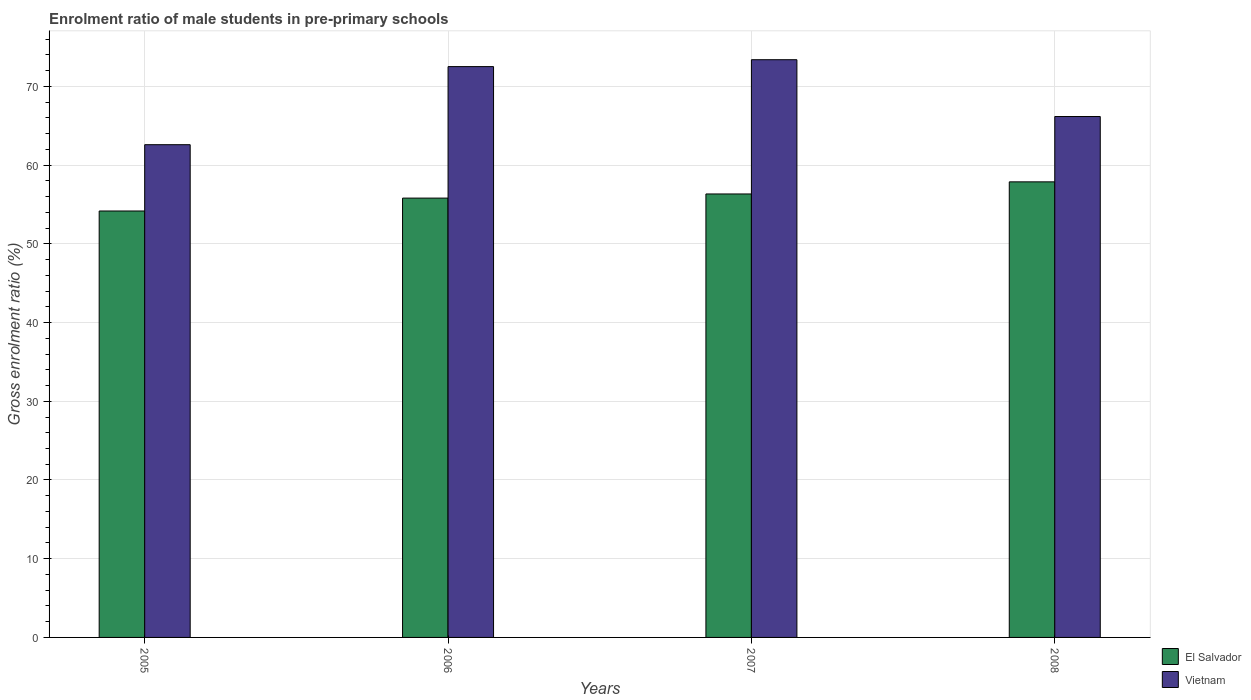How many different coloured bars are there?
Your answer should be compact. 2. How many groups of bars are there?
Your answer should be very brief. 4. Are the number of bars on each tick of the X-axis equal?
Your answer should be compact. Yes. How many bars are there on the 2nd tick from the right?
Provide a succinct answer. 2. What is the label of the 2nd group of bars from the left?
Provide a succinct answer. 2006. In how many cases, is the number of bars for a given year not equal to the number of legend labels?
Your answer should be compact. 0. What is the enrolment ratio of male students in pre-primary schools in Vietnam in 2007?
Provide a succinct answer. 73.39. Across all years, what is the maximum enrolment ratio of male students in pre-primary schools in Vietnam?
Your response must be concise. 73.39. Across all years, what is the minimum enrolment ratio of male students in pre-primary schools in Vietnam?
Your answer should be very brief. 62.59. What is the total enrolment ratio of male students in pre-primary schools in Vietnam in the graph?
Provide a succinct answer. 274.67. What is the difference between the enrolment ratio of male students in pre-primary schools in El Salvador in 2005 and that in 2008?
Ensure brevity in your answer.  -3.7. What is the difference between the enrolment ratio of male students in pre-primary schools in El Salvador in 2007 and the enrolment ratio of male students in pre-primary schools in Vietnam in 2006?
Ensure brevity in your answer.  -16.18. What is the average enrolment ratio of male students in pre-primary schools in El Salvador per year?
Your answer should be very brief. 56.05. In the year 2006, what is the difference between the enrolment ratio of male students in pre-primary schools in El Salvador and enrolment ratio of male students in pre-primary schools in Vietnam?
Offer a terse response. -16.71. What is the ratio of the enrolment ratio of male students in pre-primary schools in El Salvador in 2007 to that in 2008?
Your answer should be very brief. 0.97. Is the difference between the enrolment ratio of male students in pre-primary schools in El Salvador in 2005 and 2006 greater than the difference between the enrolment ratio of male students in pre-primary schools in Vietnam in 2005 and 2006?
Provide a short and direct response. Yes. What is the difference between the highest and the second highest enrolment ratio of male students in pre-primary schools in El Salvador?
Provide a short and direct response. 1.54. What is the difference between the highest and the lowest enrolment ratio of male students in pre-primary schools in El Salvador?
Keep it short and to the point. 3.7. In how many years, is the enrolment ratio of male students in pre-primary schools in Vietnam greater than the average enrolment ratio of male students in pre-primary schools in Vietnam taken over all years?
Ensure brevity in your answer.  2. Is the sum of the enrolment ratio of male students in pre-primary schools in Vietnam in 2005 and 2008 greater than the maximum enrolment ratio of male students in pre-primary schools in El Salvador across all years?
Provide a short and direct response. Yes. What does the 1st bar from the left in 2007 represents?
Provide a short and direct response. El Salvador. What does the 2nd bar from the right in 2006 represents?
Your answer should be very brief. El Salvador. How many bars are there?
Your answer should be very brief. 8. What is the difference between two consecutive major ticks on the Y-axis?
Make the answer very short. 10. Does the graph contain any zero values?
Your answer should be compact. No. Does the graph contain grids?
Provide a short and direct response. Yes. How many legend labels are there?
Make the answer very short. 2. How are the legend labels stacked?
Offer a very short reply. Vertical. What is the title of the graph?
Offer a very short reply. Enrolment ratio of male students in pre-primary schools. What is the label or title of the X-axis?
Your answer should be compact. Years. What is the Gross enrolment ratio (%) in El Salvador in 2005?
Give a very brief answer. 54.17. What is the Gross enrolment ratio (%) of Vietnam in 2005?
Your answer should be very brief. 62.59. What is the Gross enrolment ratio (%) in El Salvador in 2006?
Your answer should be compact. 55.81. What is the Gross enrolment ratio (%) in Vietnam in 2006?
Your answer should be compact. 72.51. What is the Gross enrolment ratio (%) of El Salvador in 2007?
Give a very brief answer. 56.33. What is the Gross enrolment ratio (%) of Vietnam in 2007?
Your answer should be very brief. 73.39. What is the Gross enrolment ratio (%) in El Salvador in 2008?
Give a very brief answer. 57.87. What is the Gross enrolment ratio (%) in Vietnam in 2008?
Make the answer very short. 66.17. Across all years, what is the maximum Gross enrolment ratio (%) in El Salvador?
Ensure brevity in your answer.  57.87. Across all years, what is the maximum Gross enrolment ratio (%) of Vietnam?
Give a very brief answer. 73.39. Across all years, what is the minimum Gross enrolment ratio (%) of El Salvador?
Your answer should be very brief. 54.17. Across all years, what is the minimum Gross enrolment ratio (%) in Vietnam?
Your answer should be very brief. 62.59. What is the total Gross enrolment ratio (%) in El Salvador in the graph?
Offer a terse response. 224.19. What is the total Gross enrolment ratio (%) of Vietnam in the graph?
Your response must be concise. 274.67. What is the difference between the Gross enrolment ratio (%) in El Salvador in 2005 and that in 2006?
Offer a terse response. -1.64. What is the difference between the Gross enrolment ratio (%) in Vietnam in 2005 and that in 2006?
Offer a very short reply. -9.92. What is the difference between the Gross enrolment ratio (%) in El Salvador in 2005 and that in 2007?
Keep it short and to the point. -2.16. What is the difference between the Gross enrolment ratio (%) of Vietnam in 2005 and that in 2007?
Your answer should be compact. -10.8. What is the difference between the Gross enrolment ratio (%) in El Salvador in 2005 and that in 2008?
Provide a succinct answer. -3.7. What is the difference between the Gross enrolment ratio (%) of Vietnam in 2005 and that in 2008?
Give a very brief answer. -3.58. What is the difference between the Gross enrolment ratio (%) of El Salvador in 2006 and that in 2007?
Ensure brevity in your answer.  -0.53. What is the difference between the Gross enrolment ratio (%) in Vietnam in 2006 and that in 2007?
Offer a terse response. -0.87. What is the difference between the Gross enrolment ratio (%) of El Salvador in 2006 and that in 2008?
Offer a very short reply. -2.06. What is the difference between the Gross enrolment ratio (%) in Vietnam in 2006 and that in 2008?
Offer a terse response. 6.34. What is the difference between the Gross enrolment ratio (%) in El Salvador in 2007 and that in 2008?
Make the answer very short. -1.54. What is the difference between the Gross enrolment ratio (%) of Vietnam in 2007 and that in 2008?
Ensure brevity in your answer.  7.22. What is the difference between the Gross enrolment ratio (%) in El Salvador in 2005 and the Gross enrolment ratio (%) in Vietnam in 2006?
Offer a very short reply. -18.34. What is the difference between the Gross enrolment ratio (%) in El Salvador in 2005 and the Gross enrolment ratio (%) in Vietnam in 2007?
Your answer should be compact. -19.22. What is the difference between the Gross enrolment ratio (%) in El Salvador in 2005 and the Gross enrolment ratio (%) in Vietnam in 2008?
Give a very brief answer. -12. What is the difference between the Gross enrolment ratio (%) of El Salvador in 2006 and the Gross enrolment ratio (%) of Vietnam in 2007?
Offer a terse response. -17.58. What is the difference between the Gross enrolment ratio (%) of El Salvador in 2006 and the Gross enrolment ratio (%) of Vietnam in 2008?
Your response must be concise. -10.36. What is the difference between the Gross enrolment ratio (%) in El Salvador in 2007 and the Gross enrolment ratio (%) in Vietnam in 2008?
Your response must be concise. -9.84. What is the average Gross enrolment ratio (%) in El Salvador per year?
Offer a terse response. 56.05. What is the average Gross enrolment ratio (%) in Vietnam per year?
Your response must be concise. 68.67. In the year 2005, what is the difference between the Gross enrolment ratio (%) in El Salvador and Gross enrolment ratio (%) in Vietnam?
Your answer should be compact. -8.42. In the year 2006, what is the difference between the Gross enrolment ratio (%) of El Salvador and Gross enrolment ratio (%) of Vietnam?
Give a very brief answer. -16.71. In the year 2007, what is the difference between the Gross enrolment ratio (%) in El Salvador and Gross enrolment ratio (%) in Vietnam?
Make the answer very short. -17.05. In the year 2008, what is the difference between the Gross enrolment ratio (%) of El Salvador and Gross enrolment ratio (%) of Vietnam?
Offer a very short reply. -8.3. What is the ratio of the Gross enrolment ratio (%) in El Salvador in 2005 to that in 2006?
Offer a very short reply. 0.97. What is the ratio of the Gross enrolment ratio (%) in Vietnam in 2005 to that in 2006?
Offer a terse response. 0.86. What is the ratio of the Gross enrolment ratio (%) of El Salvador in 2005 to that in 2007?
Offer a terse response. 0.96. What is the ratio of the Gross enrolment ratio (%) in Vietnam in 2005 to that in 2007?
Your answer should be compact. 0.85. What is the ratio of the Gross enrolment ratio (%) of El Salvador in 2005 to that in 2008?
Offer a terse response. 0.94. What is the ratio of the Gross enrolment ratio (%) of Vietnam in 2005 to that in 2008?
Your answer should be compact. 0.95. What is the ratio of the Gross enrolment ratio (%) in El Salvador in 2006 to that in 2007?
Give a very brief answer. 0.99. What is the ratio of the Gross enrolment ratio (%) of El Salvador in 2006 to that in 2008?
Your answer should be compact. 0.96. What is the ratio of the Gross enrolment ratio (%) in Vietnam in 2006 to that in 2008?
Your response must be concise. 1.1. What is the ratio of the Gross enrolment ratio (%) of El Salvador in 2007 to that in 2008?
Ensure brevity in your answer.  0.97. What is the ratio of the Gross enrolment ratio (%) in Vietnam in 2007 to that in 2008?
Make the answer very short. 1.11. What is the difference between the highest and the second highest Gross enrolment ratio (%) of El Salvador?
Offer a terse response. 1.54. What is the difference between the highest and the second highest Gross enrolment ratio (%) in Vietnam?
Keep it short and to the point. 0.87. What is the difference between the highest and the lowest Gross enrolment ratio (%) of El Salvador?
Keep it short and to the point. 3.7. What is the difference between the highest and the lowest Gross enrolment ratio (%) of Vietnam?
Ensure brevity in your answer.  10.8. 